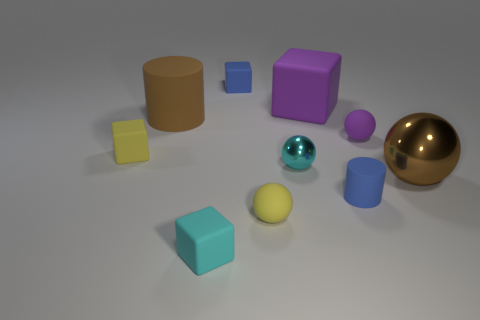Subtract 1 cubes. How many cubes are left? 3 Subtract all tiny matte cubes. How many cubes are left? 1 Subtract all cyan cubes. How many cubes are left? 3 Subtract all cyan cubes. Subtract all blue cylinders. How many cubes are left? 3 Add 7 brown things. How many brown things are left? 9 Add 7 big purple matte cylinders. How many big purple matte cylinders exist? 7 Subtract 1 blue blocks. How many objects are left? 9 Subtract all cubes. How many objects are left? 6 Subtract all big purple rubber objects. Subtract all big brown shiny spheres. How many objects are left? 8 